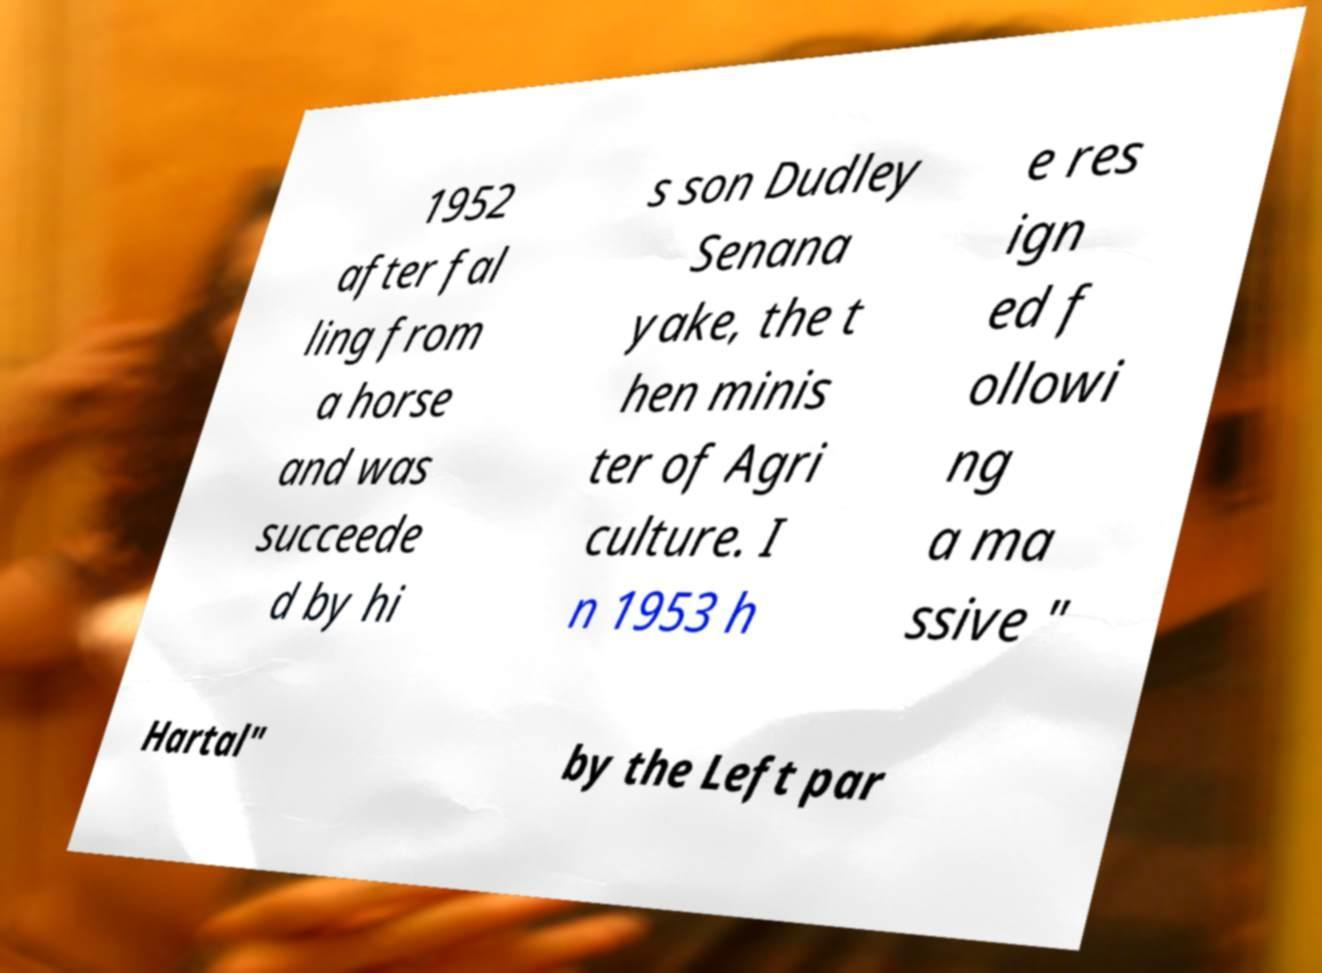Please read and relay the text visible in this image. What does it say? 1952 after fal ling from a horse and was succeede d by hi s son Dudley Senana yake, the t hen minis ter of Agri culture. I n 1953 h e res ign ed f ollowi ng a ma ssive " Hartal" by the Left par 